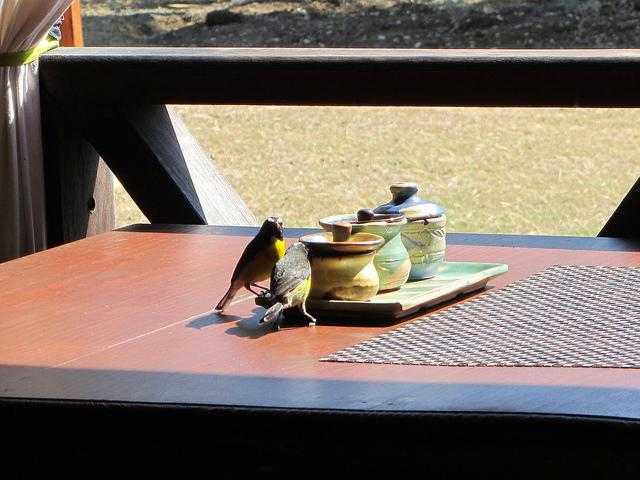Where is this table located at?

Choices:
A) dinning room
B) backyard
C) restaurant
D) patio patio 